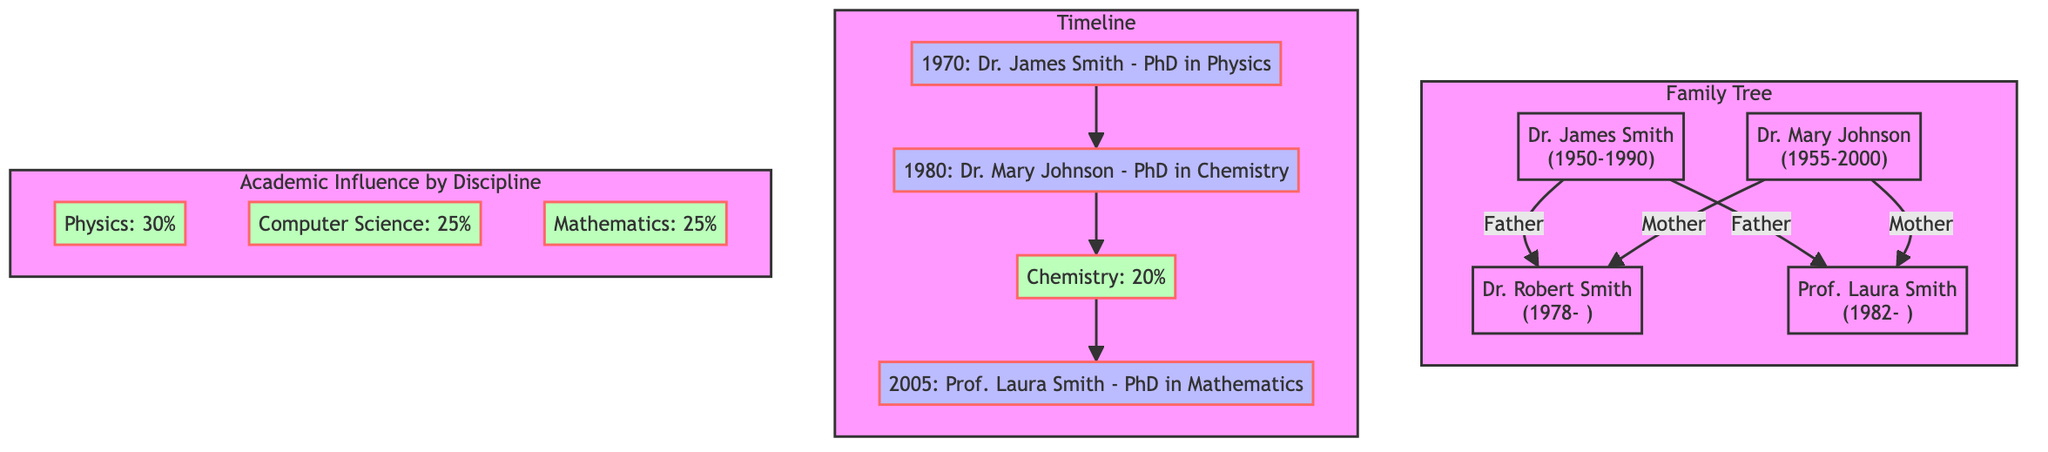What are the names of the first-generation family members? The first generation consists of Dr. James Smith and Dr. Mary Johnson, as shown in the family tree.
Answer: Dr. James Smith, Dr. Mary Johnson Who is the last child of Dr. James Smith and Dr. Mary Johnson? According to the family tree, both Dr. Robert Smith and Prof. Laura Smith are children of Dr. James Smith and Dr. Mary Johnson. The last child listed is Prof. Laura Smith.
Answer: Prof. Laura Smith What year did Dr. Mary Johnson complete her PhD? In the timeline, it states that Dr. Mary Johnson completed her PhD in Chemistry in 1980.
Answer: 1980 How many total academic disciplines are represented in the academic influence section? The diagram shows four disciplines: Physics, Chemistry, Computer Science, and Mathematics, which counts as four disciplines total.
Answer: 4 Which discipline has the highest percentage in academic influence? A pie chart presents percentages for different disciplines, showing Physics at 30%, more than any other discipline.
Answer: Physics What is the combined percentage of Computer Science and Mathematics in academic influence? To find the combined percentage, add the values for Computer Science (25%) and Mathematics (25%): 25% + 25% = 50%.
Answer: 50% Who received their PhD in Computer Science? The timeline indicates that Dr. Robert Smith received his PhD in Computer Science in 1998.
Answer: Dr. Robert Smith Which two family members completed their PhDs after 1990? The data shows that Dr. Robert Smith completed his PhD in 1998 and Prof. Laura Smith completed hers in 2005. Both are after 1990.
Answer: Dr. Robert Smith, Prof. Laura Smith What is the relationship between Prof. Laura Smith and Dr. James Smith? The family tree shows that Prof. Laura Smith is the daughter of Dr. James Smith.
Answer: Daughter 